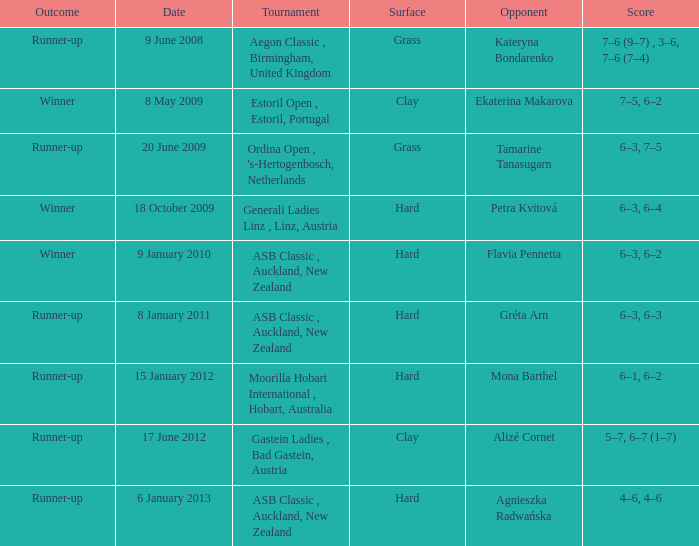What was the result in the competition against ekaterina makarova? 7–5, 6–2. 